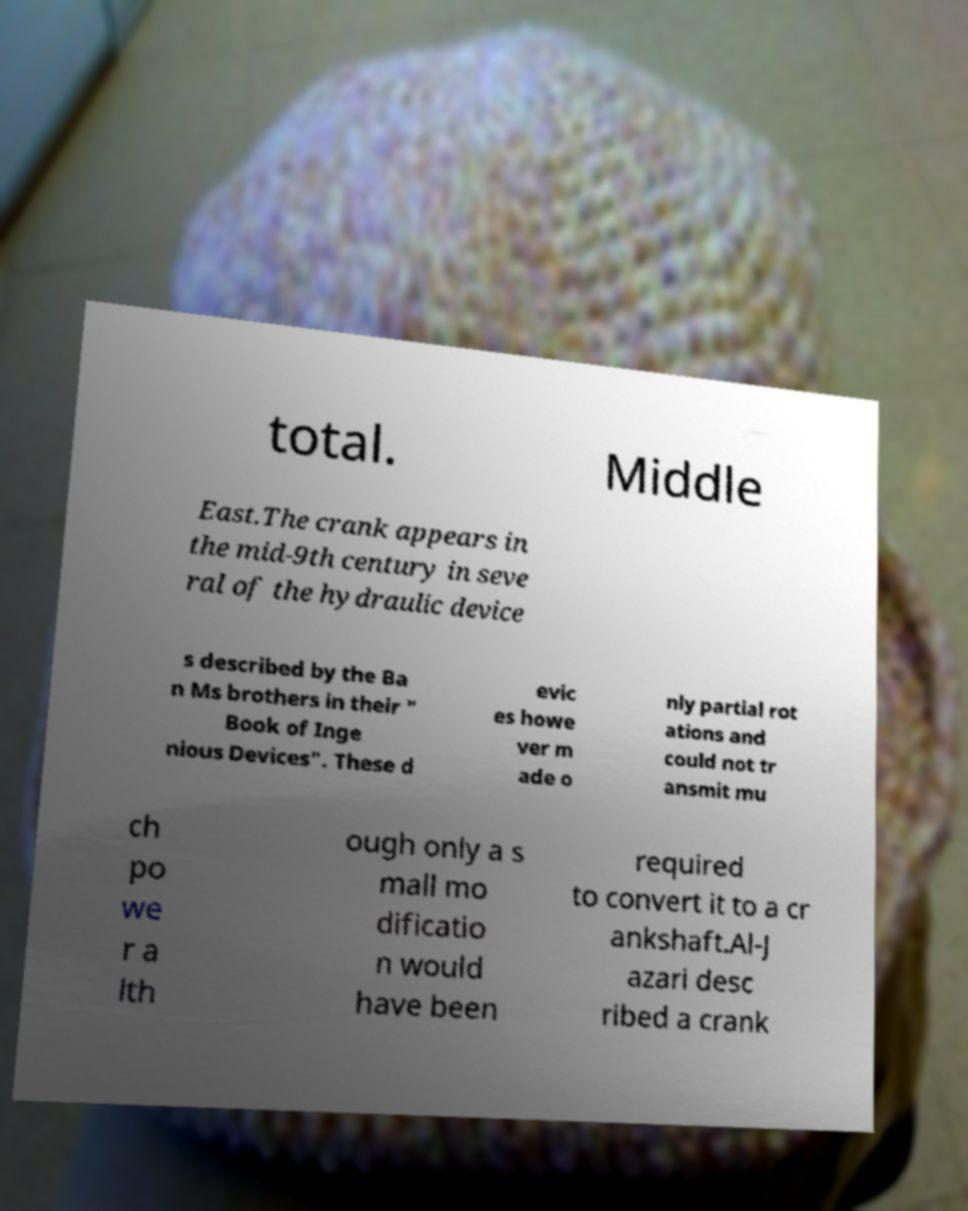For documentation purposes, I need the text within this image transcribed. Could you provide that? total. Middle East.The crank appears in the mid-9th century in seve ral of the hydraulic device s described by the Ba n Ms brothers in their " Book of Inge nious Devices". These d evic es howe ver m ade o nly partial rot ations and could not tr ansmit mu ch po we r a lth ough only a s mall mo dificatio n would have been required to convert it to a cr ankshaft.Al-J azari desc ribed a crank 